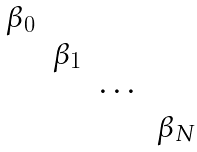Convert formula to latex. <formula><loc_0><loc_0><loc_500><loc_500>\begin{matrix} \beta _ { 0 } & & & \\ & \beta _ { 1 } & & \\ & & \cdots & \\ & & & \beta _ { N } \\ \end{matrix}</formula> 